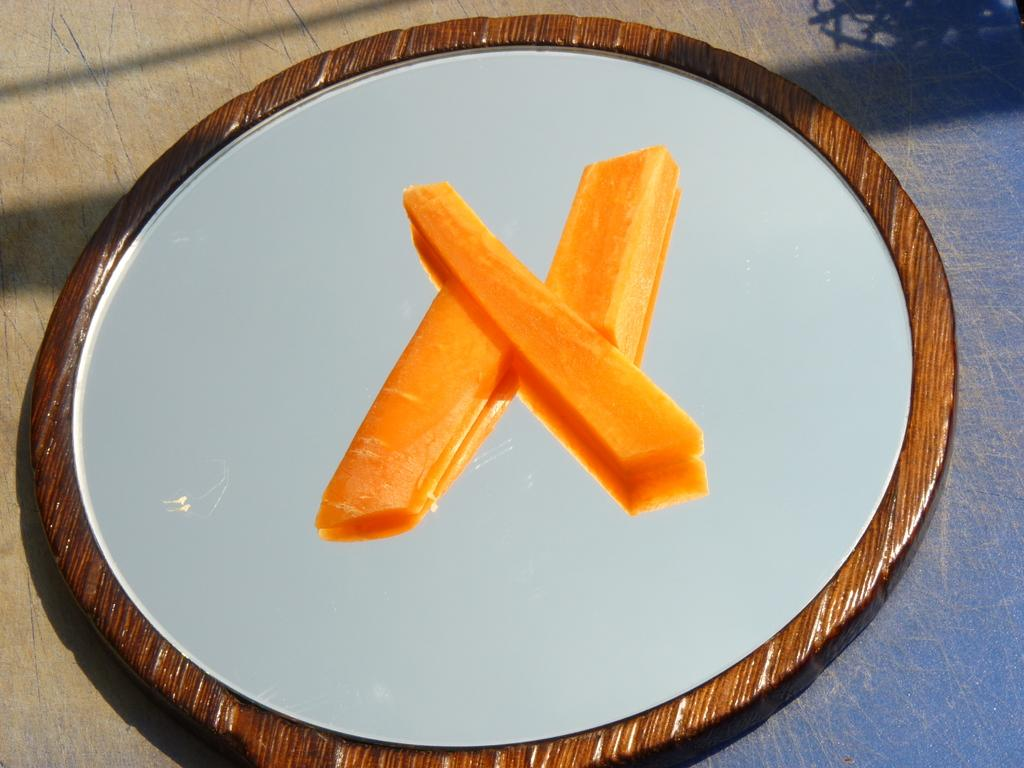What type of food can be seen in the image? There are carrot pieces in the image. Where are the carrot pieces located? The carrot pieces are on a circular mirror. What is the shape of the surface on which the circular mirror is placed? The information provided does not specify the shape of the surface. What is the purpose of the circular mirror in the image? The purpose of the circular mirror is not explicitly stated, but it is being used as a surface for the carrot pieces. What type of stamp can be seen on the carrot pieces in the image? There is no stamp present on the carrot pieces in the image. Can you describe the bee that is buzzing around the carrot pieces in the image? There are no bees present in the image; it only features carrot pieces on a circular mirror. 